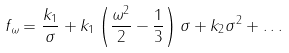<formula> <loc_0><loc_0><loc_500><loc_500>f _ { \omega } = \frac { k _ { 1 } } { \sigma } + k _ { 1 } \left ( \frac { \omega ^ { 2 } } { 2 } - \frac { 1 } { 3 } \right ) \sigma + k _ { 2 } \sigma ^ { 2 } + \dots</formula> 